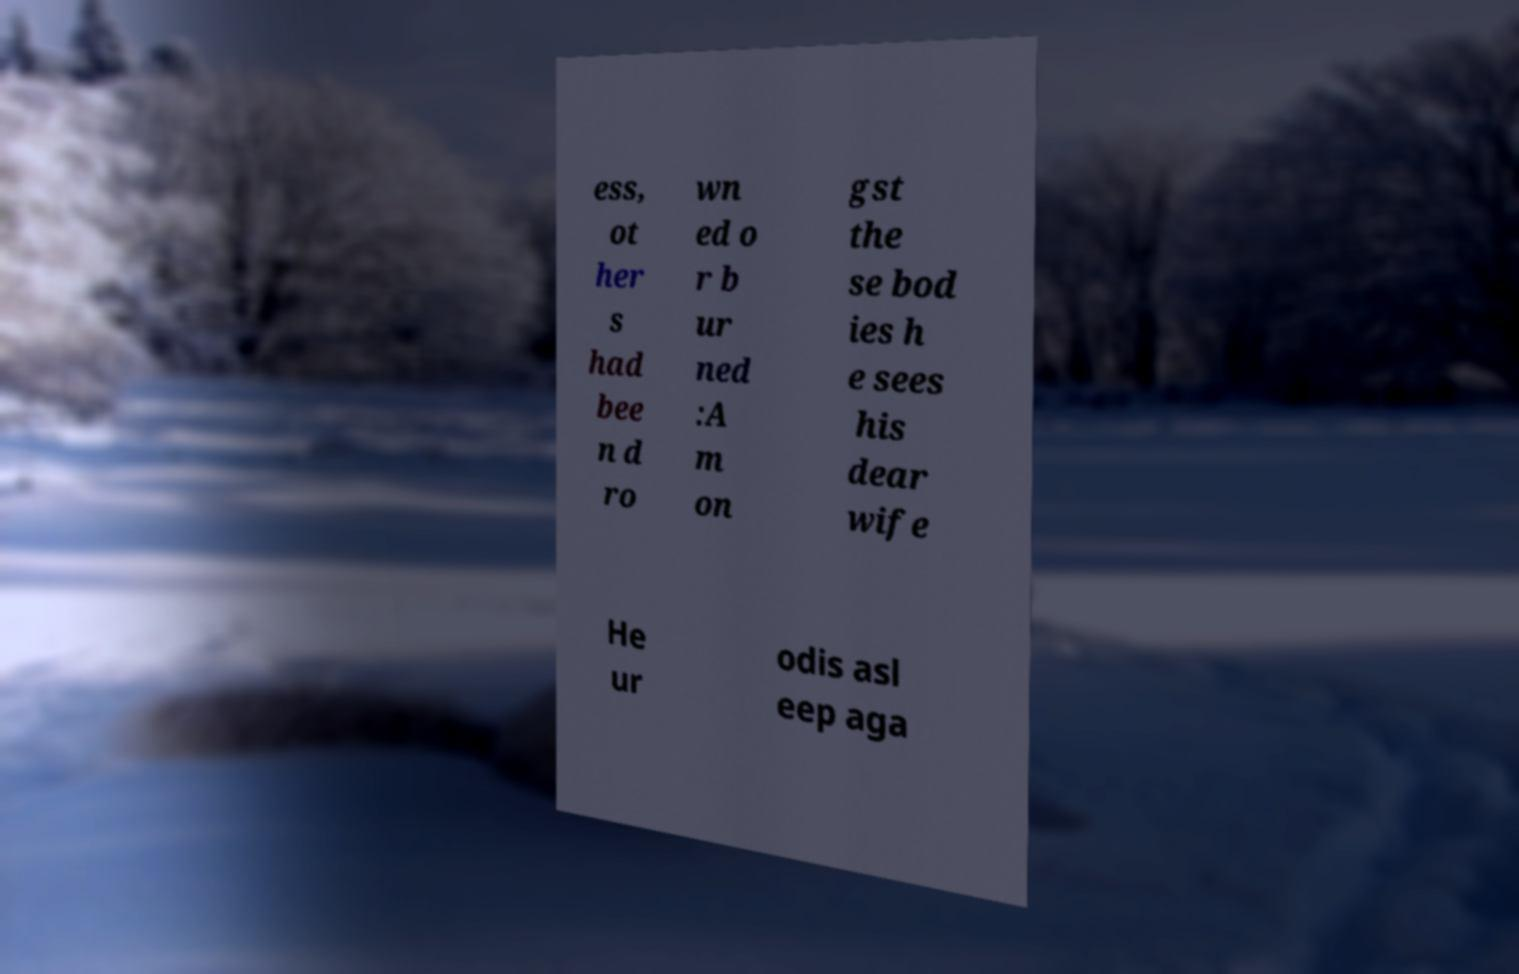Can you accurately transcribe the text from the provided image for me? ess, ot her s had bee n d ro wn ed o r b ur ned :A m on gst the se bod ies h e sees his dear wife He ur odis asl eep aga 